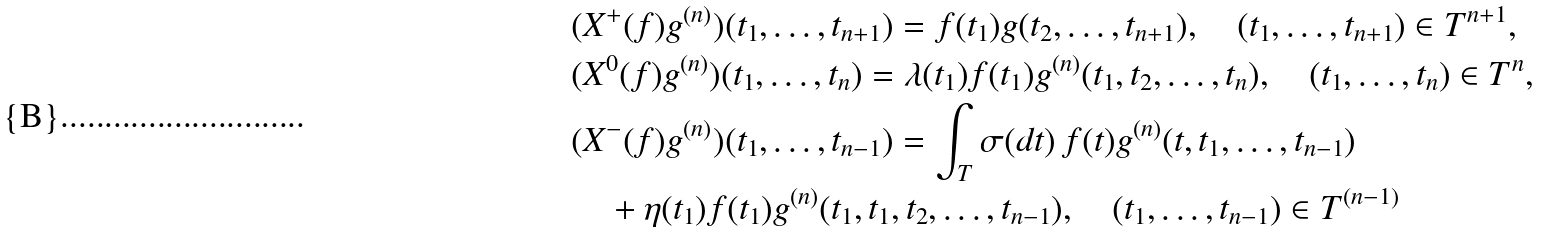Convert formula to latex. <formula><loc_0><loc_0><loc_500><loc_500>& ( X ^ { + } ( f ) g ^ { ( n ) } ) ( t _ { 1 } , \dots , t _ { n + 1 } ) = f ( t _ { 1 } ) g ( t _ { 2 } , \dots , t _ { n + 1 } ) , \quad ( t _ { 1 } , \dots , t _ { n + 1 } ) \in T ^ { n + 1 } , \\ & ( X ^ { 0 } ( f ) g ^ { ( n ) } ) ( t _ { 1 } , \dots , t _ { n } ) = \lambda ( t _ { 1 } ) f ( t _ { 1 } ) g ^ { ( n ) } ( t _ { 1 } , t _ { 2 } , \dots , t _ { n } ) , \quad ( t _ { 1 } , \dots , t _ { n } ) \in T ^ { n } , \\ & ( X ^ { - } ( f ) g ^ { ( n ) } ) ( t _ { 1 } , \dots , t _ { n - 1 } ) = \int _ { T } \sigma ( d t ) \, f ( t ) g ^ { ( n ) } ( t , t _ { 1 } , \dots , t _ { n - 1 } ) \\ & \quad + \eta ( t _ { 1 } ) f ( t _ { 1 } ) g ^ { ( n ) } ( t _ { 1 } , t _ { 1 } , t _ { 2 } , \dots , t _ { n - 1 } ) , \quad ( t _ { 1 } , \dots , t _ { n - 1 } ) \in T ^ { ( n - 1 ) }</formula> 